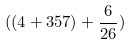<formula> <loc_0><loc_0><loc_500><loc_500>( ( 4 + 3 5 7 ) + \frac { 6 } { 2 6 } )</formula> 